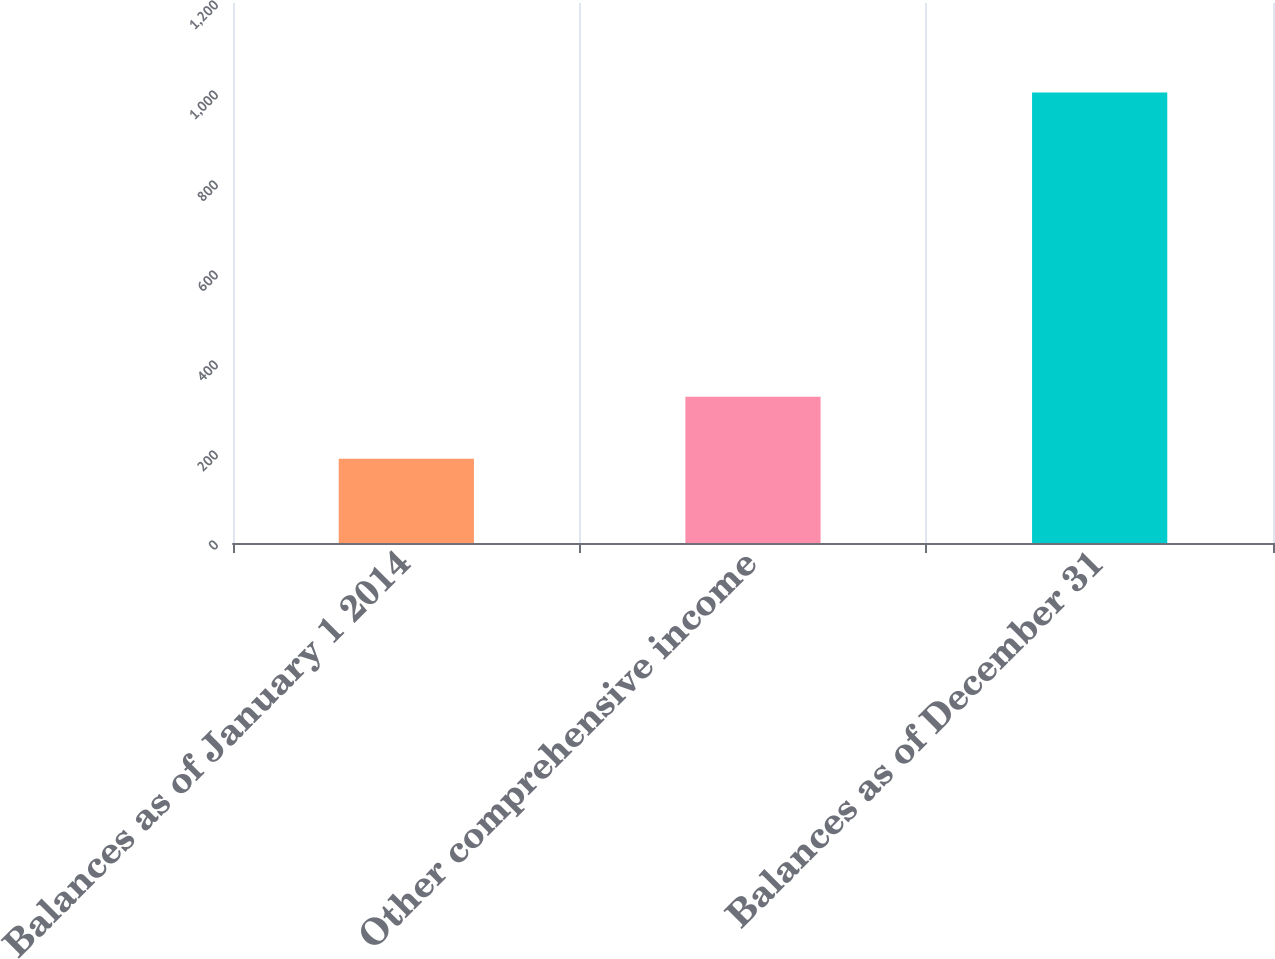Convert chart to OTSL. <chart><loc_0><loc_0><loc_500><loc_500><bar_chart><fcel>Balances as of January 1 2014<fcel>Other comprehensive income<fcel>Balances as of December 31<nl><fcel>187<fcel>325<fcel>1001<nl></chart> 